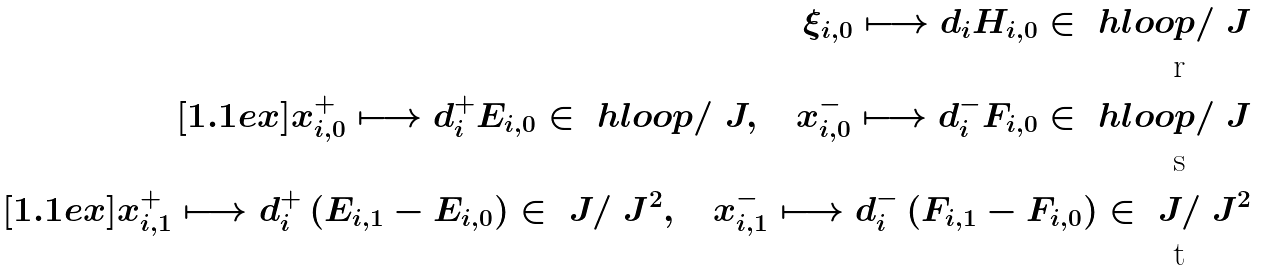Convert formula to latex. <formula><loc_0><loc_0><loc_500><loc_500>\xi _ { i , 0 } \longmapsto d _ { i } H _ { i , 0 } \in \ h l o o p / \ J \\ [ 1 . 1 e x ] x ^ { + } _ { i , 0 } \longmapsto d _ { i } ^ { + } E _ { i , 0 } \in \ h l o o p / \ J , \quad x ^ { - } _ { i , 0 } \longmapsto d _ { i } ^ { - } F _ { i , 0 } \in \ h l o o p / \ J \\ [ 1 . 1 e x ] x ^ { + } _ { i , 1 } \longmapsto d _ { i } ^ { + } \, ( E _ { i , 1 } - E _ { i , 0 } ) \in \ J / \ J ^ { 2 } , \quad x ^ { - } _ { i , 1 } \longmapsto d _ { i } ^ { - } \, ( F _ { i , 1 } - F _ { i , 0 } ) \in \ J / \ J ^ { 2 }</formula> 